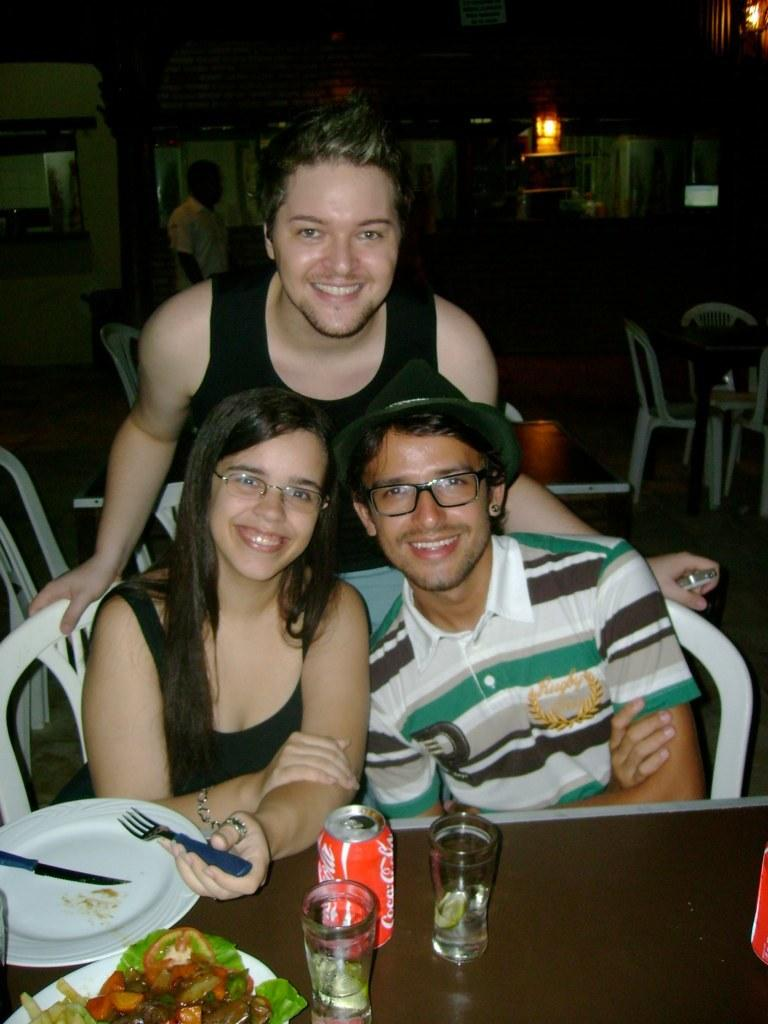How many people are in the image? There are three persons in the image. Can you describe the gender of the people in the image? Two of the persons are men, and one is a woman. What are the people in the image doing? The three persons are sitting in chairs, while one man is standing in front of a table. What can be seen on the table? There are different items on the table. What type of crown is the woman wearing in the image? There is no crown present in the image; the woman is not wearing any headgear. Can you hear any thunder in the image? The image is silent, and there is no mention of any sound, including thunder. 